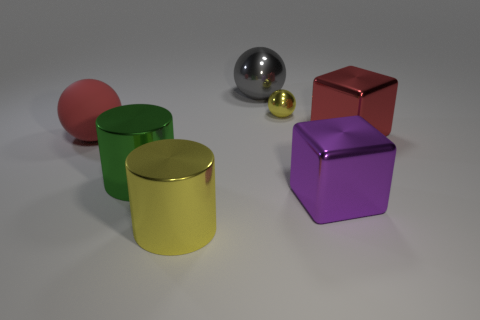Add 3 big cubes. How many objects exist? 10 Subtract all blocks. How many objects are left? 5 Subtract all small cyan balls. Subtract all large gray spheres. How many objects are left? 6 Add 1 big red objects. How many big red objects are left? 3 Add 3 cylinders. How many cylinders exist? 5 Subtract 1 yellow cylinders. How many objects are left? 6 